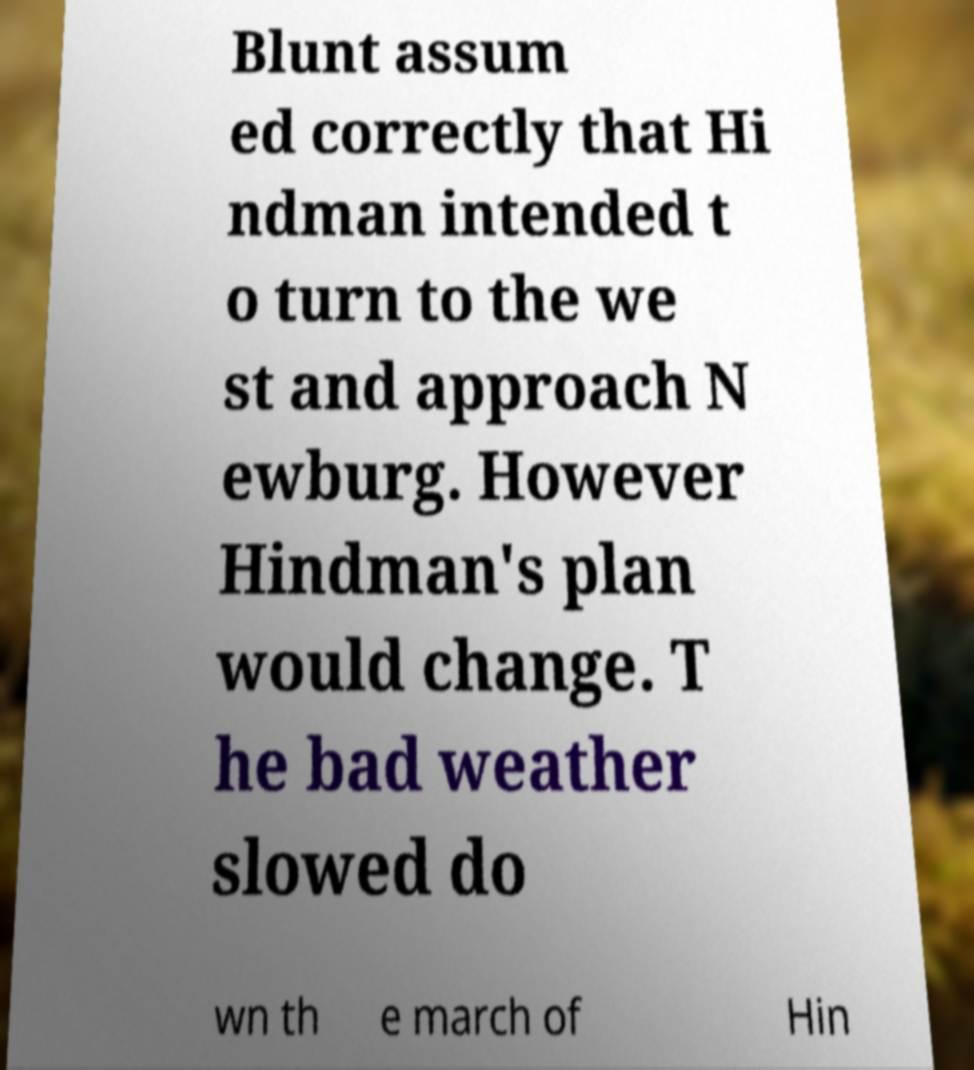Could you assist in decoding the text presented in this image and type it out clearly? Blunt assum ed correctly that Hi ndman intended t o turn to the we st and approach N ewburg. However Hindman's plan would change. T he bad weather slowed do wn th e march of Hin 